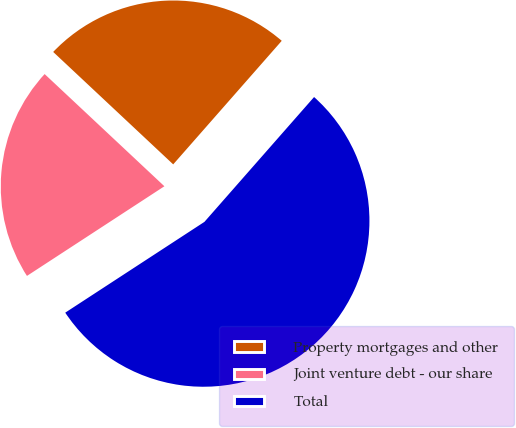Convert chart to OTSL. <chart><loc_0><loc_0><loc_500><loc_500><pie_chart><fcel>Property mortgages and other<fcel>Joint venture debt - our share<fcel>Total<nl><fcel>24.49%<fcel>21.18%<fcel>54.33%<nl></chart> 